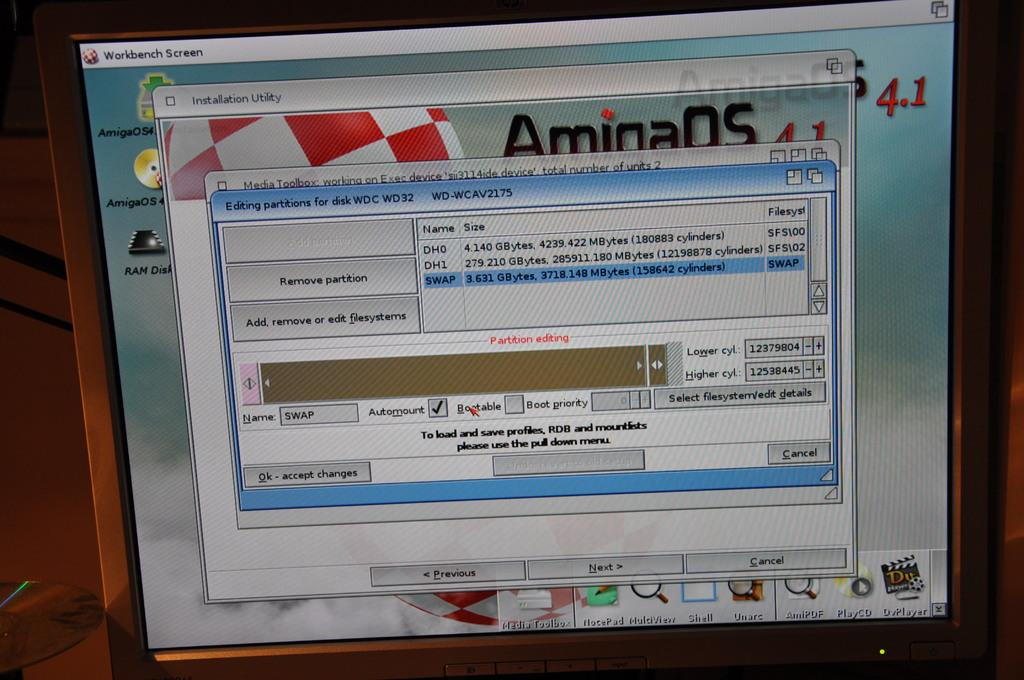<image>
Summarize the visual content of the image. A computer screen window open that has AminaOS 4.1 